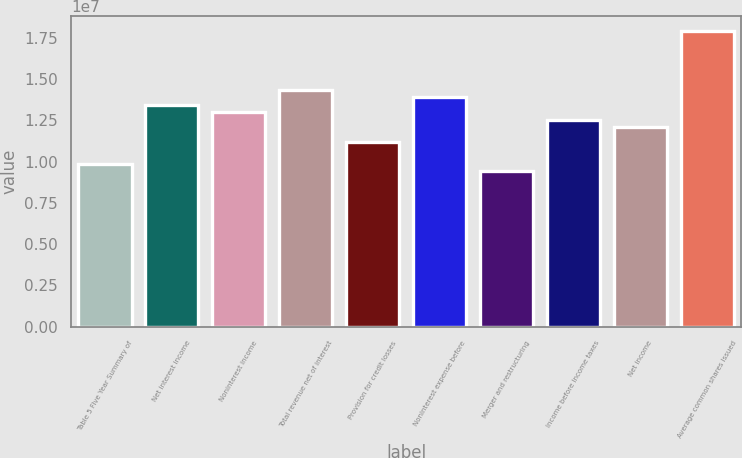Convert chart to OTSL. <chart><loc_0><loc_0><loc_500><loc_500><bar_chart><fcel>Table 5 Five Year Summary of<fcel>Net interest income<fcel>Noninterest income<fcel>Total revenue net of interest<fcel>Provision for credit losses<fcel>Noninterest expense before<fcel>Merger and restructuring<fcel>Income before income taxes<fcel>Net income<fcel>Average common shares issued<nl><fcel>9.85656e+06<fcel>1.34408e+07<fcel>1.29927e+07<fcel>1.43368e+07<fcel>1.12006e+07<fcel>1.38888e+07<fcel>9.40853e+06<fcel>1.25447e+07<fcel>1.20967e+07<fcel>1.7921e+07<nl></chart> 